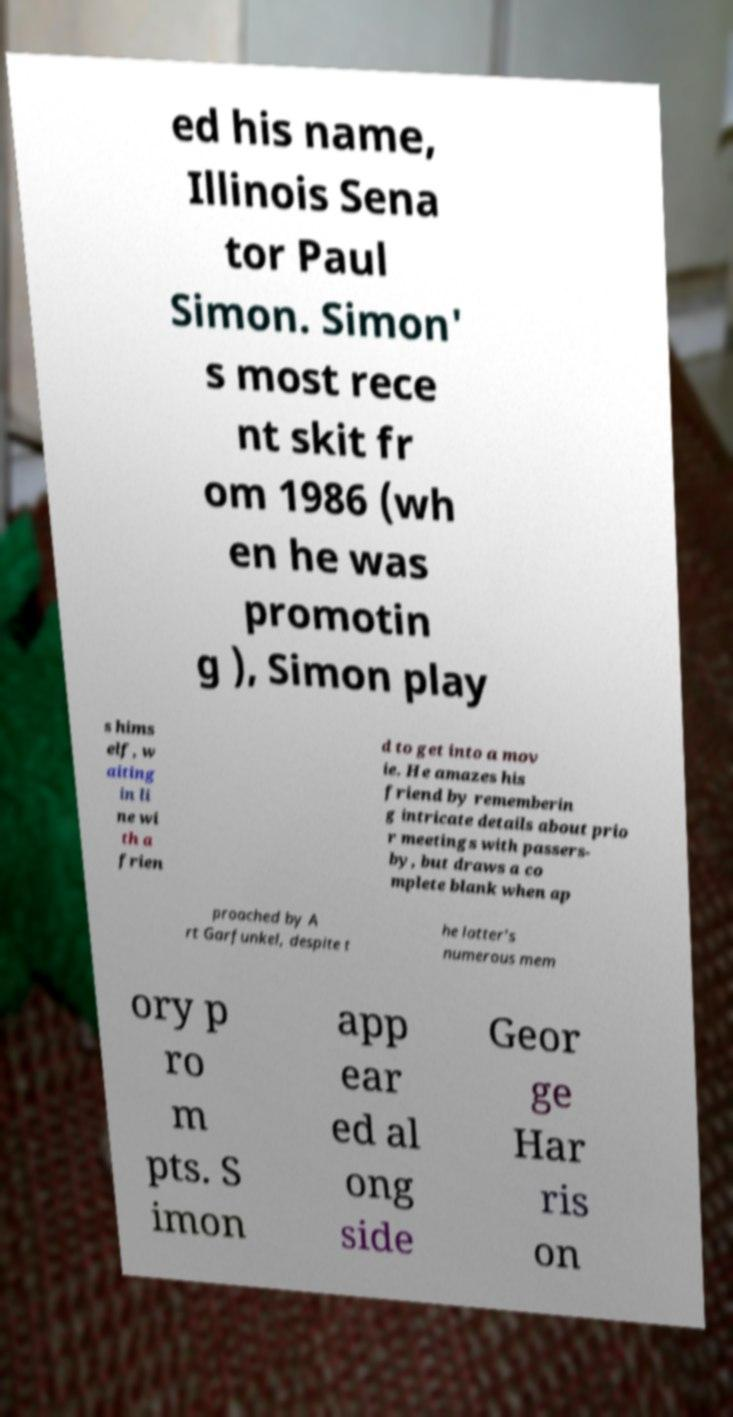Could you extract and type out the text from this image? ed his name, Illinois Sena tor Paul Simon. Simon' s most rece nt skit fr om 1986 (wh en he was promotin g ), Simon play s hims elf, w aiting in li ne wi th a frien d to get into a mov ie. He amazes his friend by rememberin g intricate details about prio r meetings with passers- by, but draws a co mplete blank when ap proached by A rt Garfunkel, despite t he latter's numerous mem ory p ro m pts. S imon app ear ed al ong side Geor ge Har ris on 